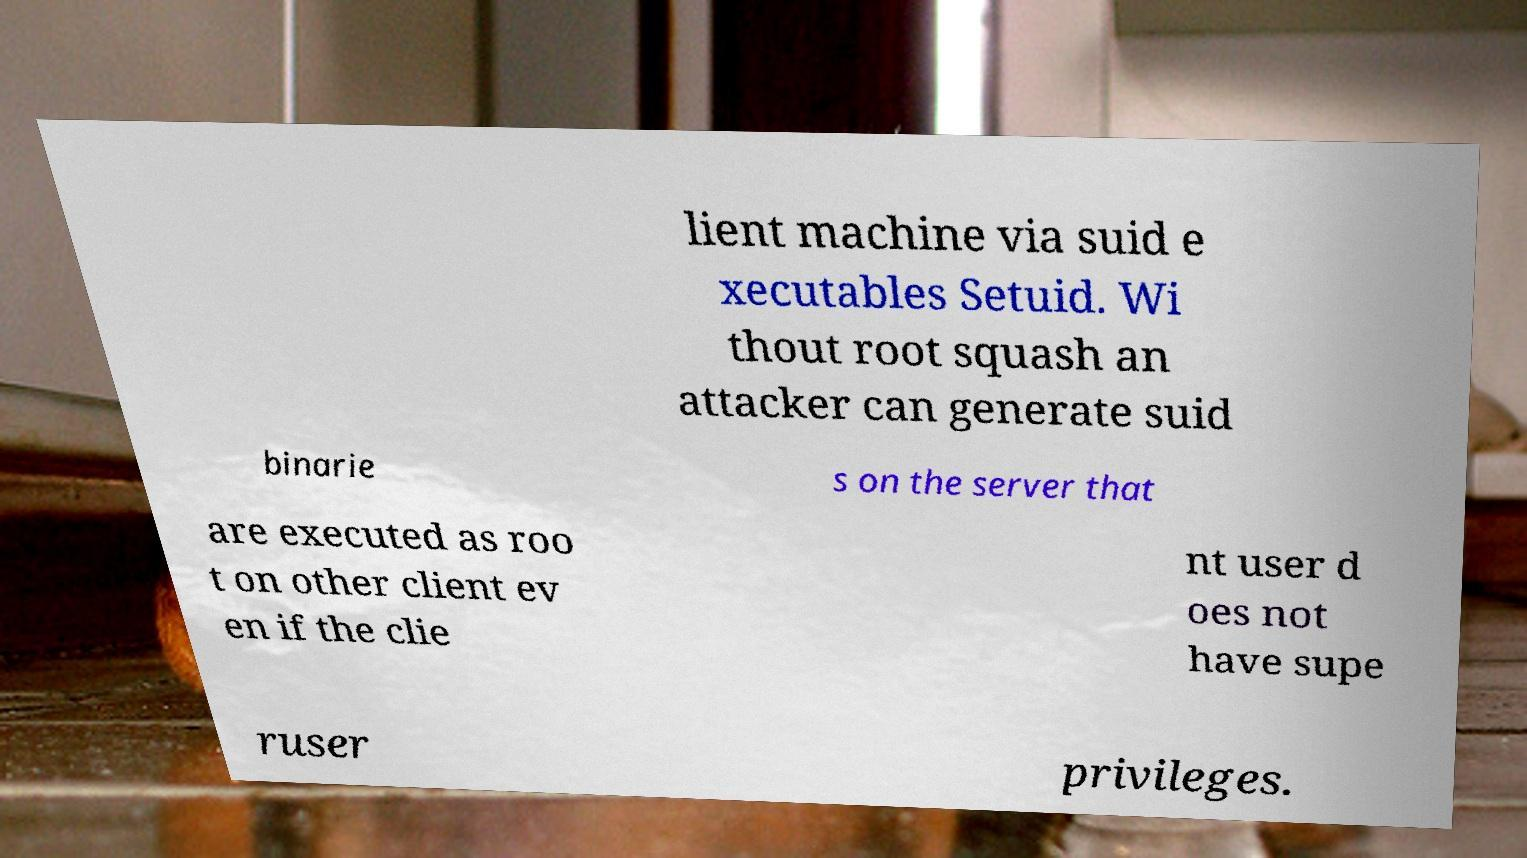Could you extract and type out the text from this image? lient machine via suid e xecutables Setuid. Wi thout root squash an attacker can generate suid binarie s on the server that are executed as roo t on other client ev en if the clie nt user d oes not have supe ruser privileges. 